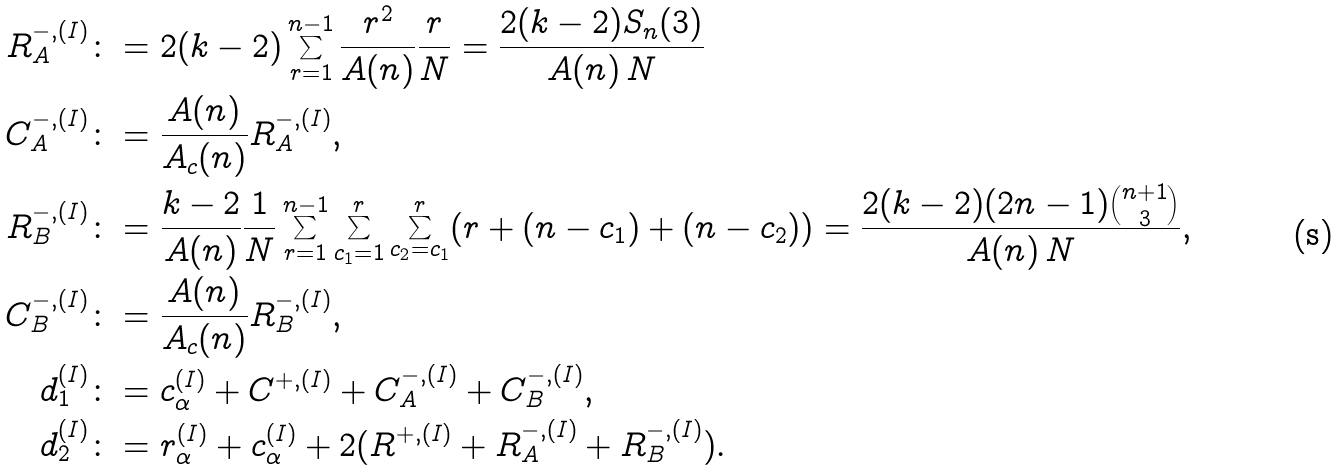Convert formula to latex. <formula><loc_0><loc_0><loc_500><loc_500>R _ { A } ^ { - , ( I ) } & \colon = 2 ( k - 2 ) \sum _ { r = 1 } ^ { n - 1 } \frac { r ^ { 2 } } { A ( n ) } \frac { r } { N } = \frac { 2 ( k - 2 ) S _ { n } ( 3 ) } { A ( n ) \, N } \\ C _ { A } ^ { - , ( I ) } & \colon = \frac { A ( n ) } { A _ { c } ( n ) } R _ { A } ^ { - , ( I ) } , \\ R _ { B } ^ { - , ( I ) } & \colon = \frac { k - 2 } { A ( n ) } \frac { 1 } { N } \sum _ { r = 1 } ^ { n - 1 } \sum _ { c _ { 1 } = 1 } ^ { r } \sum _ { c _ { 2 } = c _ { 1 } } ^ { r } ( r + ( n - c _ { 1 } ) + ( n - c _ { 2 } ) ) = \frac { 2 ( k - 2 ) ( 2 n - 1 ) \binom { n + 1 } { 3 } } { A ( n ) \, N } , \\ C _ { B } ^ { - , ( I ) } & \colon = \frac { A ( n ) } { A _ { c } ( n ) } R _ { B } ^ { - , ( I ) } , \\ d _ { 1 } ^ { ( I ) } & \colon = c _ { \alpha } ^ { ( I ) } + C ^ { + , ( I ) } + C _ { A } ^ { - , ( I ) } + C _ { B } ^ { - , ( I ) } , \\ d _ { 2 } ^ { ( I ) } & \colon = r _ { \alpha } ^ { ( I ) } + c _ { \alpha } ^ { ( I ) } + 2 ( R ^ { + , ( I ) } + R _ { A } ^ { - , ( I ) } + R _ { B } ^ { - , ( I ) } ) . \\</formula> 